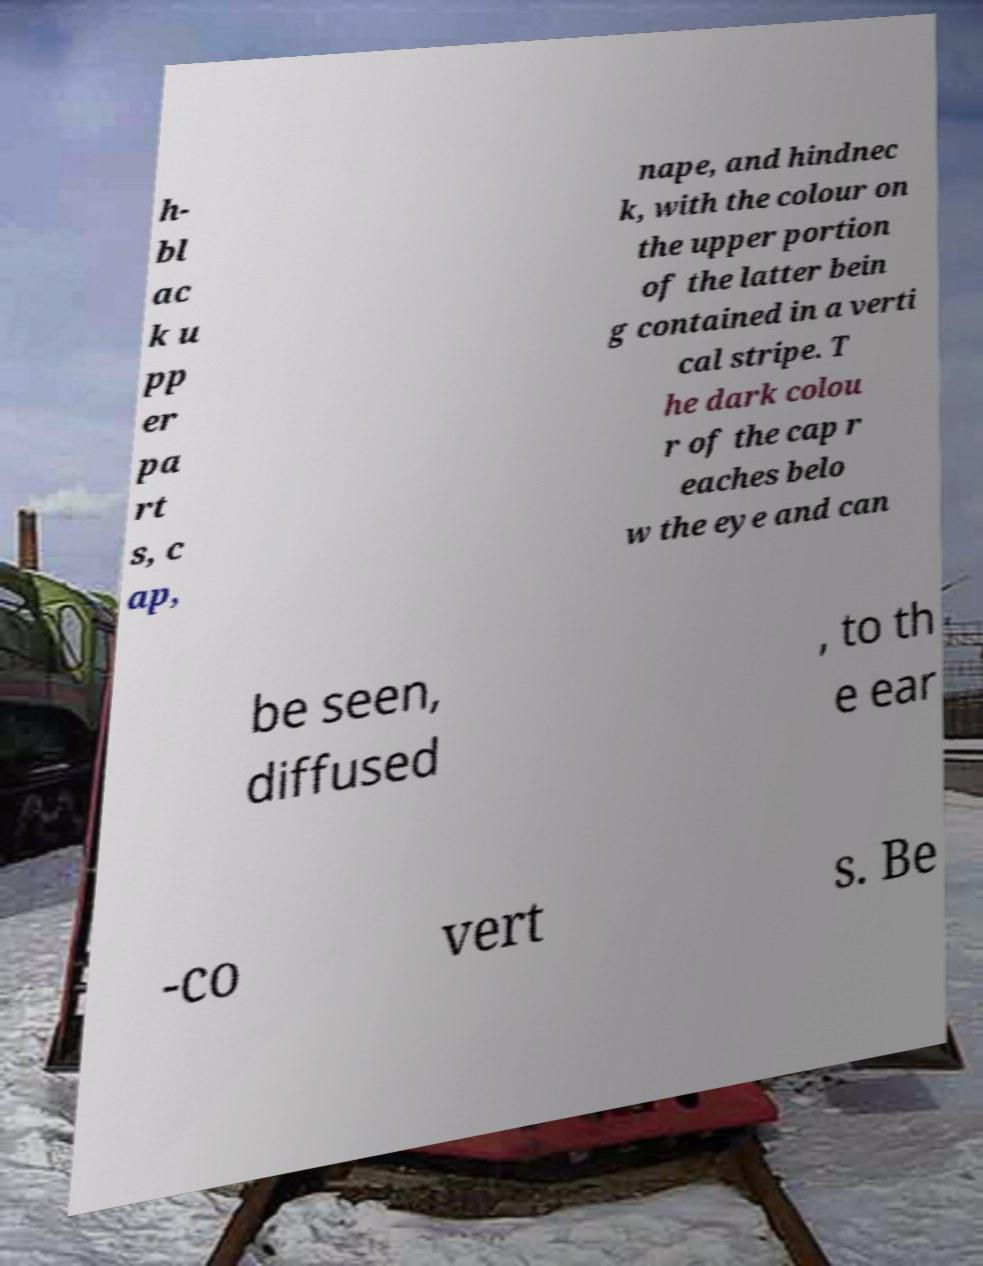What messages or text are displayed in this image? I need them in a readable, typed format. h- bl ac k u pp er pa rt s, c ap, nape, and hindnec k, with the colour on the upper portion of the latter bein g contained in a verti cal stripe. T he dark colou r of the cap r eaches belo w the eye and can be seen, diffused , to th e ear -co vert s. Be 